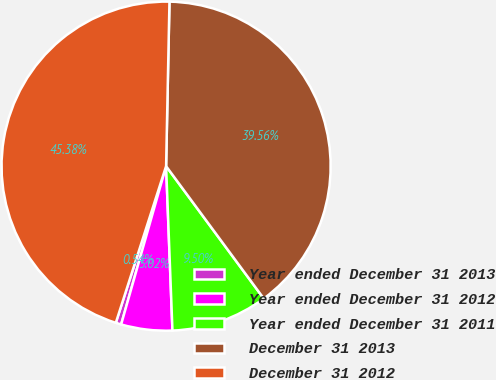Convert chart. <chart><loc_0><loc_0><loc_500><loc_500><pie_chart><fcel>Year ended December 31 2013<fcel>Year ended December 31 2012<fcel>Year ended December 31 2011<fcel>December 31 2013<fcel>December 31 2012<nl><fcel>0.54%<fcel>5.02%<fcel>9.5%<fcel>39.56%<fcel>45.38%<nl></chart> 